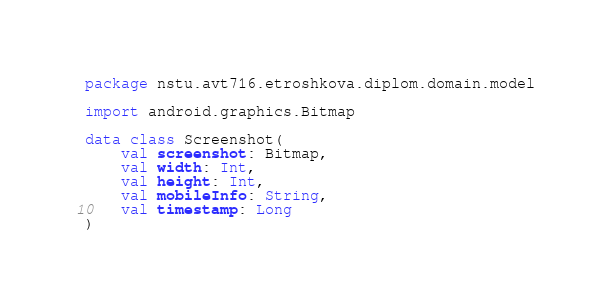<code> <loc_0><loc_0><loc_500><loc_500><_Kotlin_>package nstu.avt716.etroshkova.diplom.domain.model

import android.graphics.Bitmap

data class Screenshot(
    val screenshot: Bitmap,
    val width: Int,
    val height: Int,
    val mobileInfo: String,
    val timestamp: Long
)
</code> 